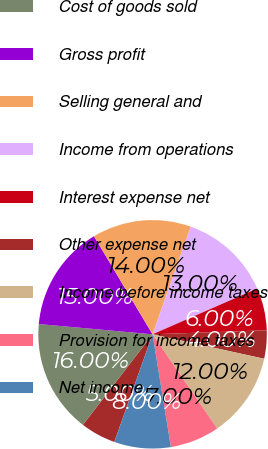<chart> <loc_0><loc_0><loc_500><loc_500><pie_chart><fcel>(In thousands except per share<fcel>Cost of goods sold<fcel>Gross profit<fcel>Selling general and<fcel>Income from operations<fcel>Interest expense net<fcel>Other expense net<fcel>Income before income taxes<fcel>Provision for income taxes<fcel>Net income<nl><fcel>5.0%<fcel>16.0%<fcel>15.0%<fcel>14.0%<fcel>13.0%<fcel>6.0%<fcel>4.0%<fcel>12.0%<fcel>7.0%<fcel>8.0%<nl></chart> 